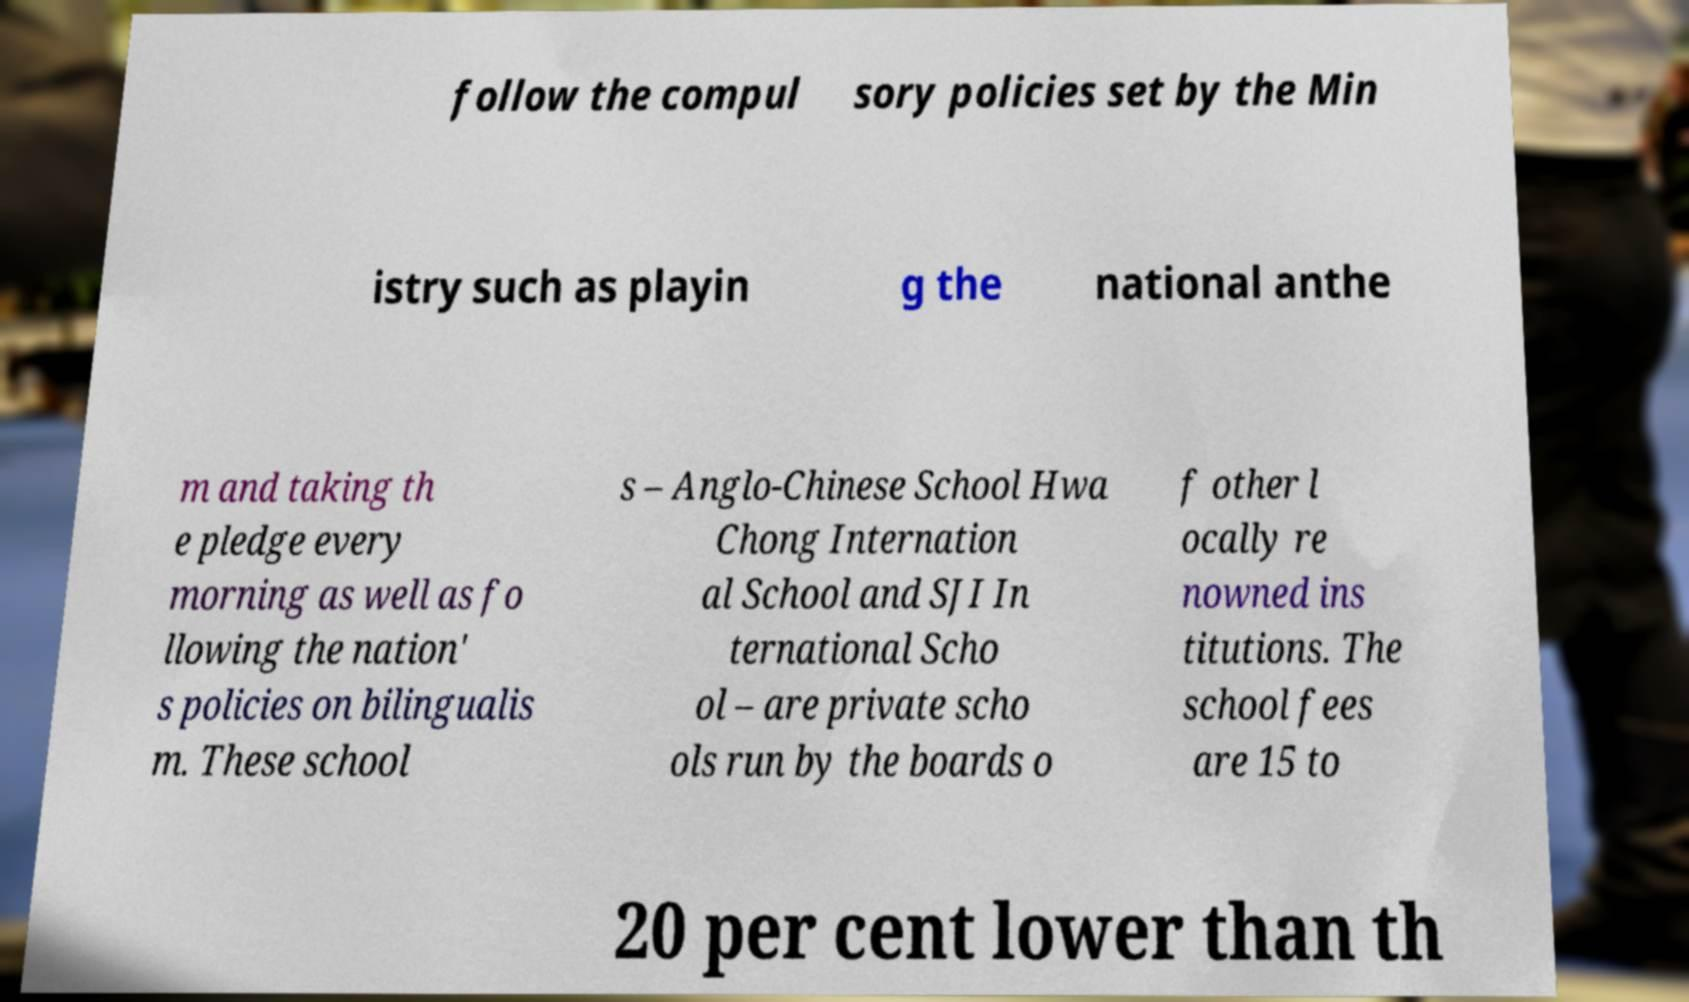Can you read and provide the text displayed in the image?This photo seems to have some interesting text. Can you extract and type it out for me? follow the compul sory policies set by the Min istry such as playin g the national anthe m and taking th e pledge every morning as well as fo llowing the nation' s policies on bilingualis m. These school s – Anglo-Chinese School Hwa Chong Internation al School and SJI In ternational Scho ol – are private scho ols run by the boards o f other l ocally re nowned ins titutions. The school fees are 15 to 20 per cent lower than th 